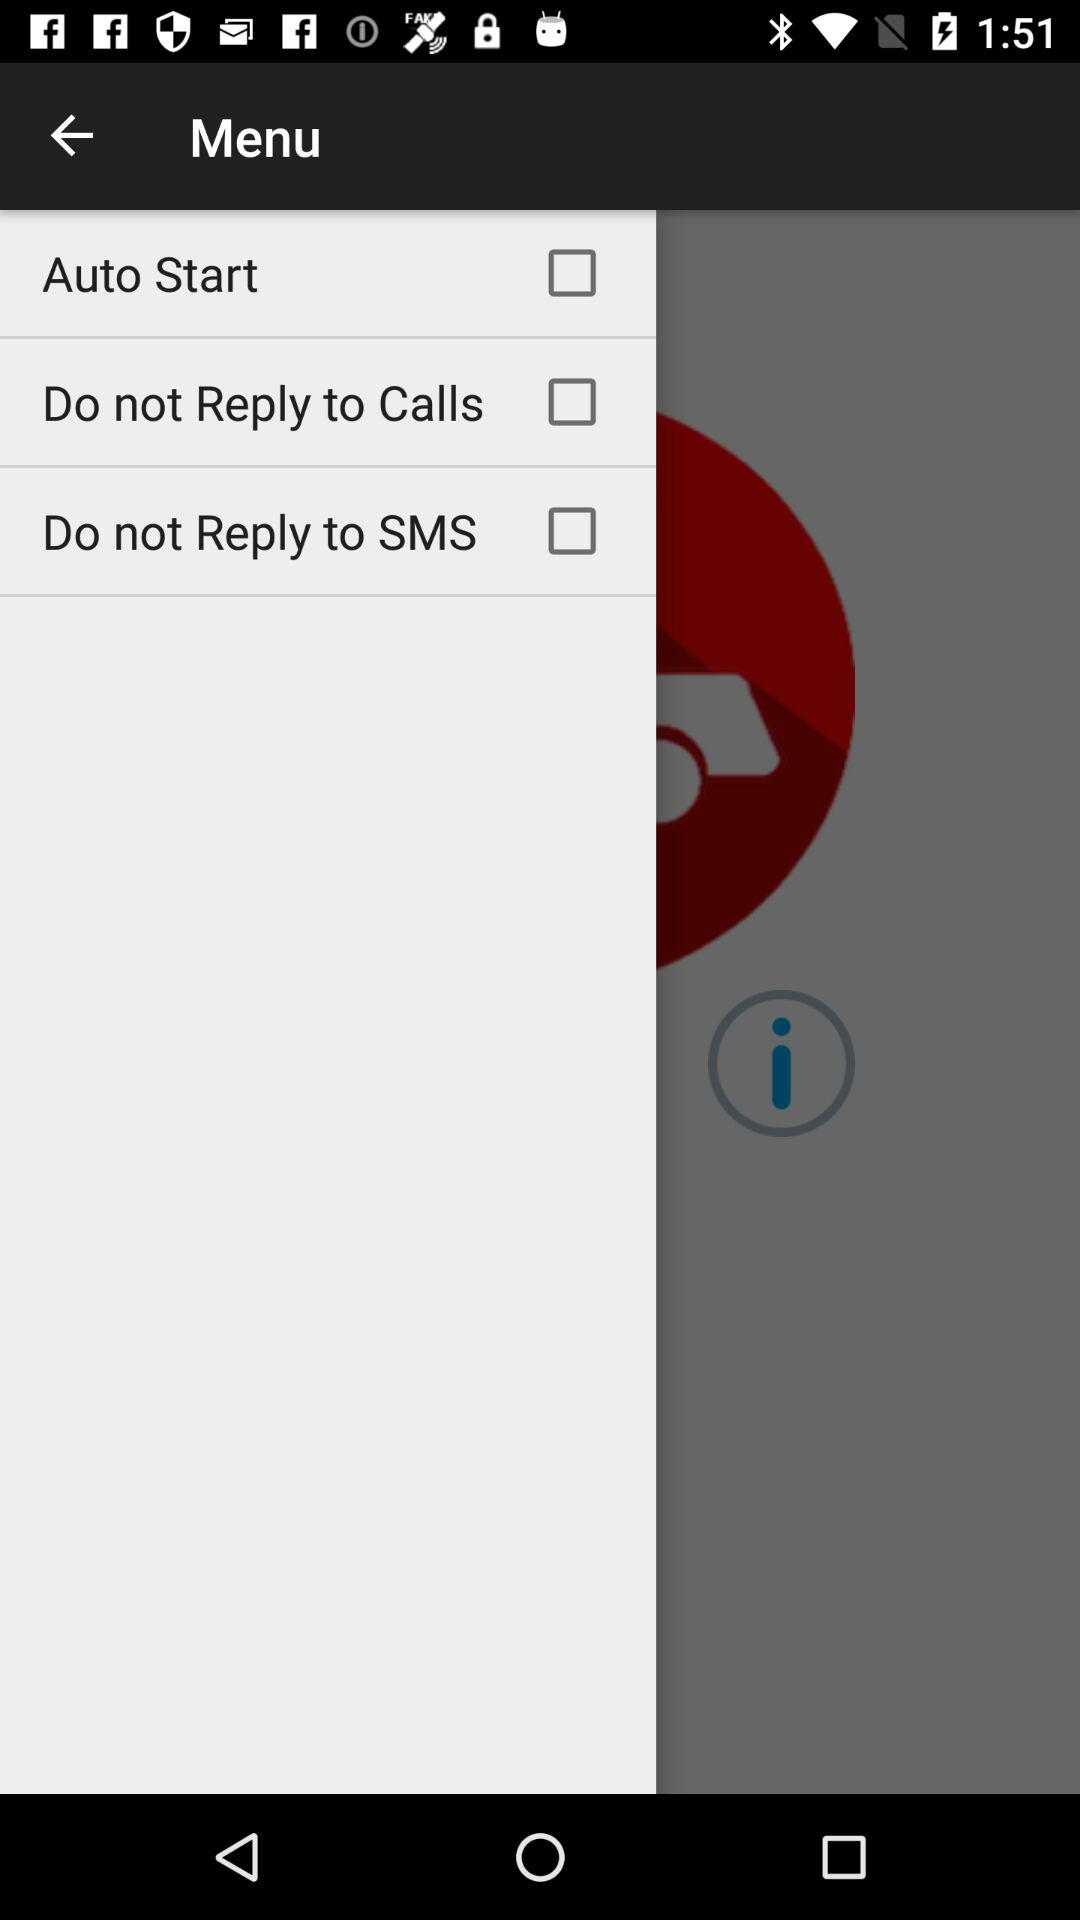What is the name of the application?
When the provided information is insufficient, respond with <no answer>. <no answer> 